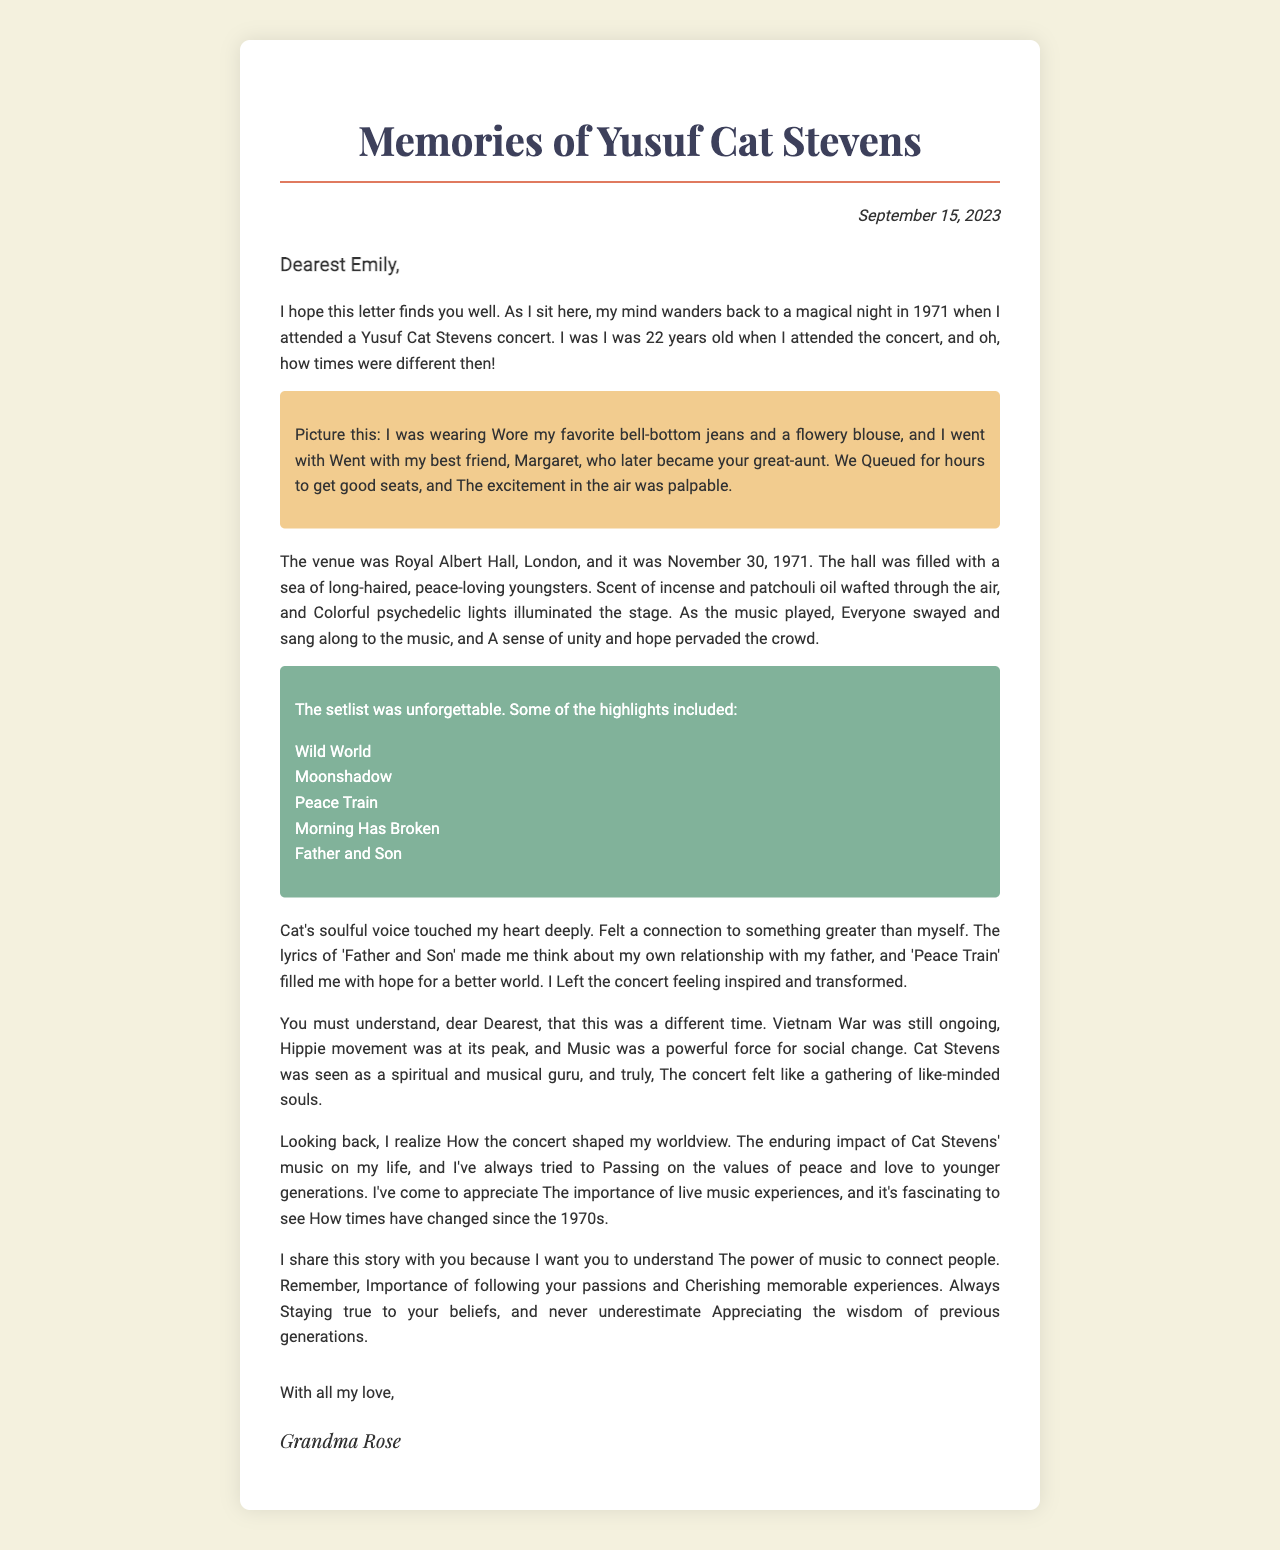what is the recipient's name? The recipient's name is mentioned in the salutation of the letter.
Answer: Dearest Emily who is the sender of the letter? The sender of the letter is identified in the closing signature.
Answer: Grandma Rose when did the Yusuf Cat Stevens concert take place? The date of the concert is specified in the concert details.
Answer: November 30, 1971 what was the venue of the concert? The venue where the concert was held is referenced in the concert details.
Answer: Royal Albert Hall, London how old was Grandma Rose when she attended the concert? The letter includes her age at the time of the concert.
Answer: 22 years old what type of clothing did Grandma Rose wear to the concert? The document describes her outfit in her personal memories.
Answer: bell-bottom jeans and a flowery blouse what is one highlight from the concert's setlist? The setlist includes multiple songs, any of which could be an answer.
Answer: Wild World why does Grandma Rose feel a connection to something greater during the concert? This feeling is expressed in relation to the emotional impact of the concert.
Answer: Cat's soulful voice touched my heart deeply how did the atmosphere of the concert feel to those attending? The document describes the overall atmosphere and feelings present at the concert.
Answer: A sense of unity and hope pervaded the crowd what message does Grandma Rose want to convey to her grandchild? The letter includes important life lessons and values she wishes to pass on.
Answer: The power of music to connect people 